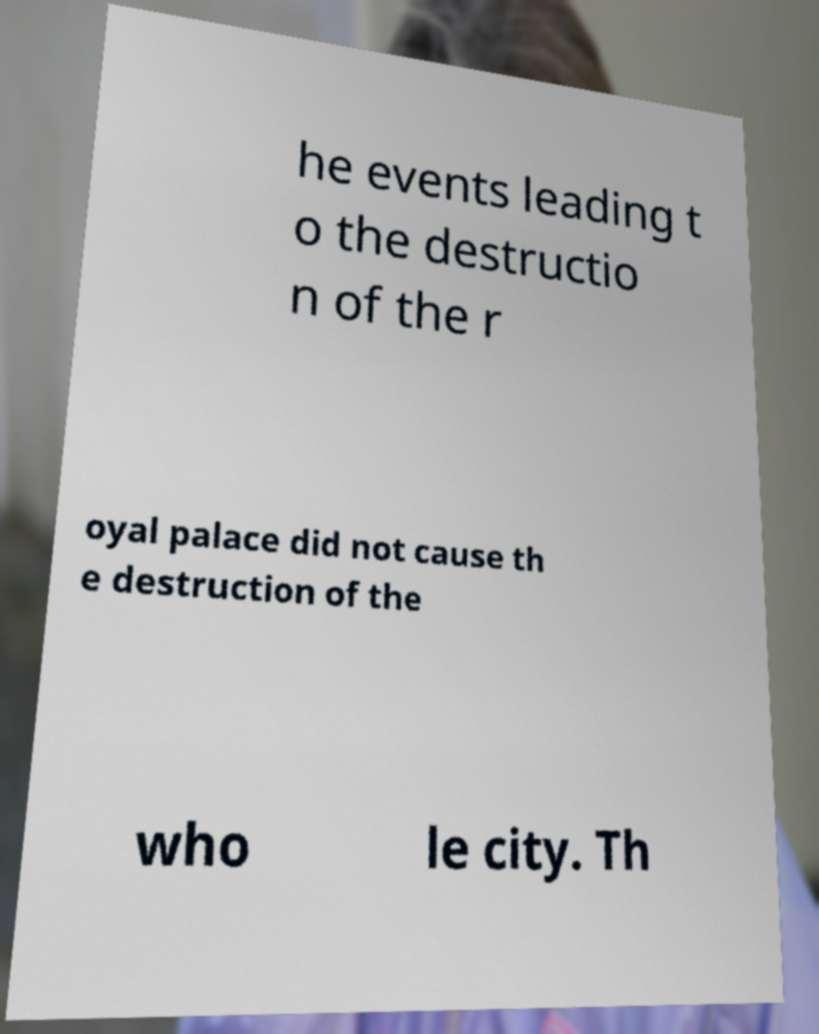Please read and relay the text visible in this image. What does it say? he events leading t o the destructio n of the r oyal palace did not cause th e destruction of the who le city. Th 